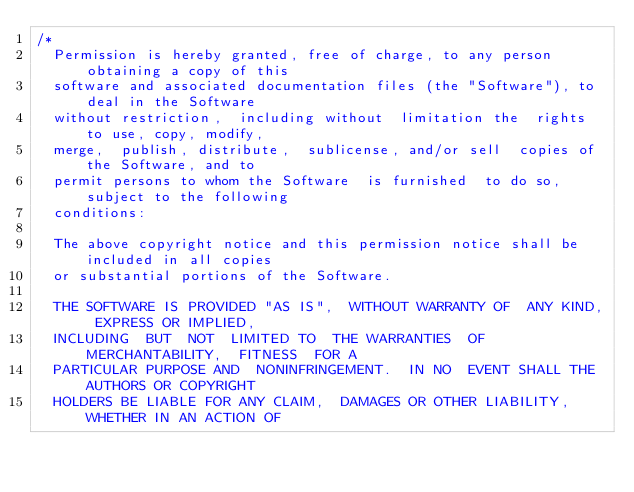Convert code to text. <code><loc_0><loc_0><loc_500><loc_500><_C#_>/*
  Permission is hereby granted, free of charge, to any person obtaining a copy of this 
  software and associated documentation files (the "Software"), to deal in the Software 
  without restriction,  including without  limitation the  rights to use, copy, modify, 
  merge,  publish, distribute,  sublicense, and/or sell  copies of the Software, and to 
  permit persons to whom the Software  is furnished  to do so, subject to the following 
  conditions:

  The above copyright notice and this permission notice shall be included in all copies
  or substantial portions of the Software.

  THE SOFTWARE IS PROVIDED "AS IS",  WITHOUT WARRANTY OF  ANY KIND, EXPRESS OR IMPLIED, 
  INCLUDING  BUT  NOT  LIMITED TO  THE WARRANTIES  OF  MERCHANTABILITY,  FITNESS  FOR A 
  PARTICULAR PURPOSE AND  NONINFRINGEMENT.  IN NO  EVENT SHALL THE AUTHORS OR COPYRIGHT 
  HOLDERS BE LIABLE FOR ANY CLAIM,  DAMAGES OR OTHER LIABILITY, WHETHER IN AN ACTION OF </code> 